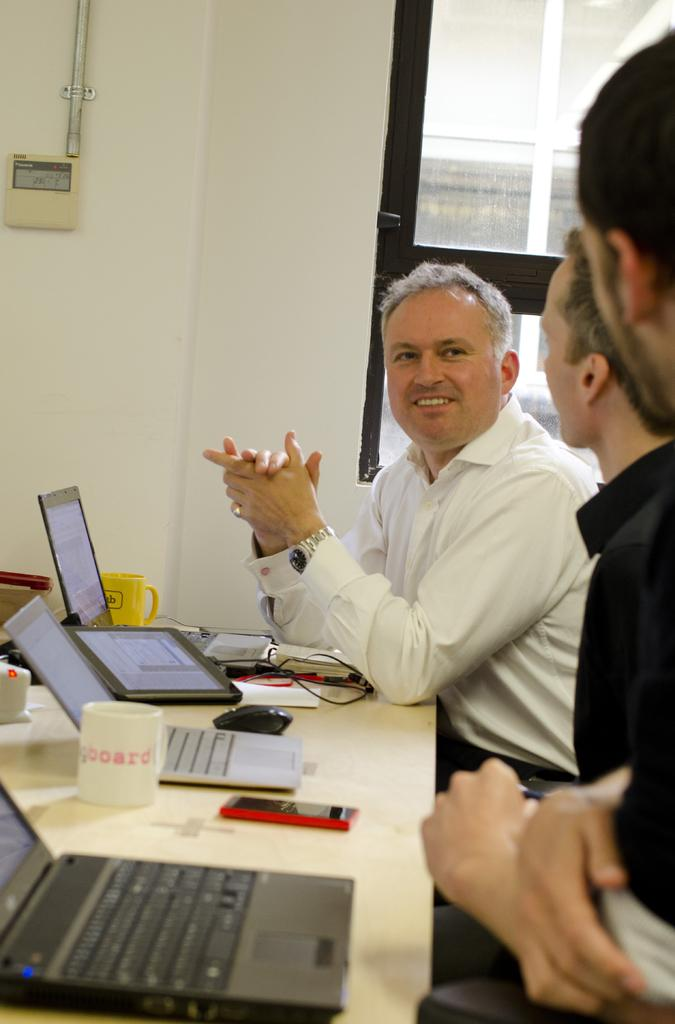<image>
Write a terse but informative summary of the picture. Man giving a talk to two other people with a cup that says "board" in front of them. 